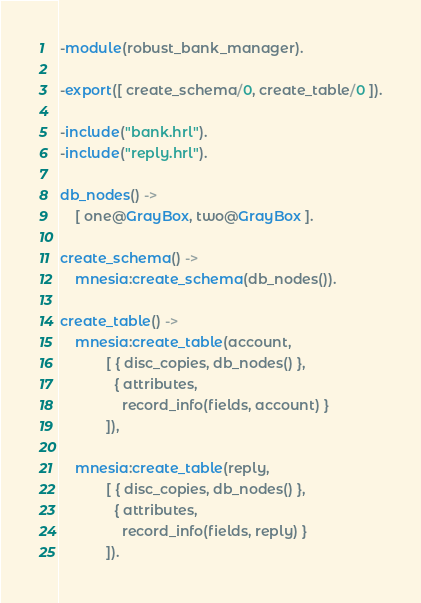Convert code to text. <code><loc_0><loc_0><loc_500><loc_500><_Erlang_>-module(robust_bank_manager).

-export([ create_schema/0, create_table/0 ]).

-include("bank.hrl").
-include("reply.hrl").

db_nodes() ->
    [ one@GrayBox, two@GrayBox ].

create_schema() ->
    mnesia:create_schema(db_nodes()).

create_table() ->
    mnesia:create_table(account,
            [ { disc_copies, db_nodes() },
              { attributes,
                record_info(fields, account) }
            ]),

    mnesia:create_table(reply,
            [ { disc_copies, db_nodes() },
              { attributes,
                record_info(fields, reply) }
            ]).</code> 